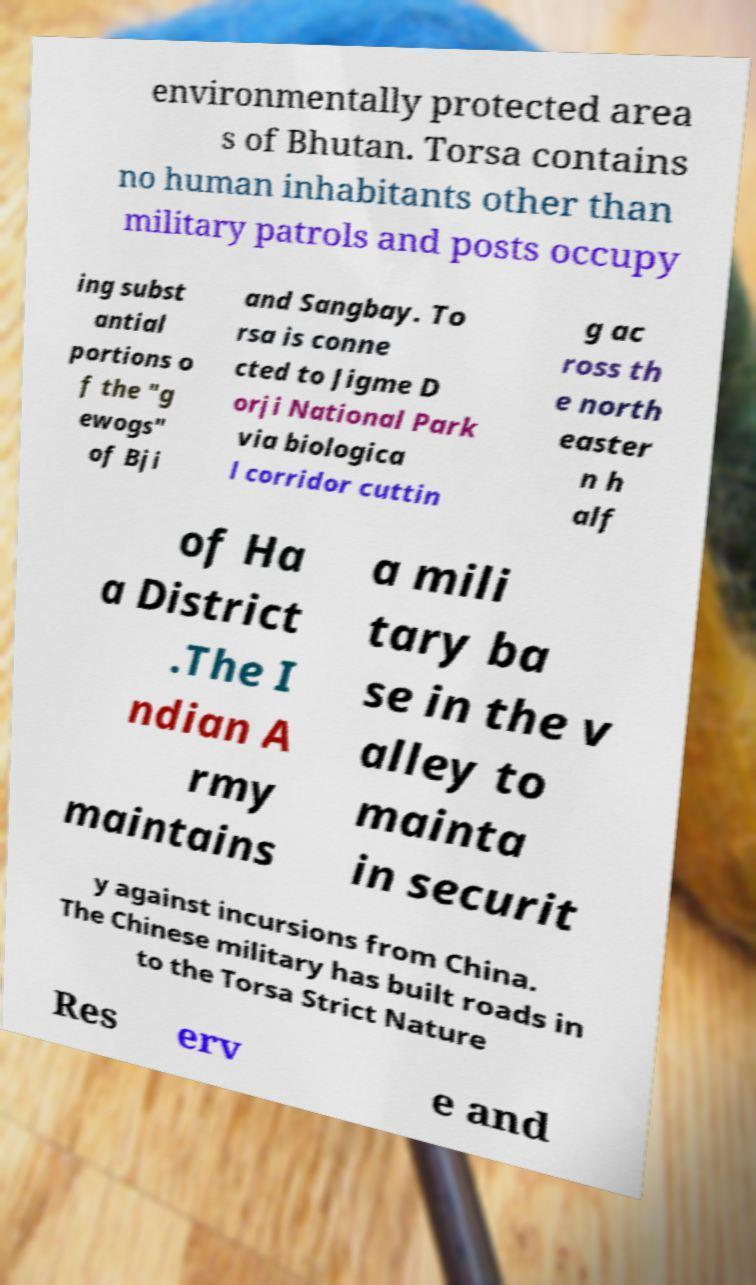I need the written content from this picture converted into text. Can you do that? environmentally protected area s of Bhutan. Torsa contains no human inhabitants other than military patrols and posts occupy ing subst antial portions o f the "g ewogs" of Bji and Sangbay. To rsa is conne cted to Jigme D orji National Park via biologica l corridor cuttin g ac ross th e north easter n h alf of Ha a District .The I ndian A rmy maintains a mili tary ba se in the v alley to mainta in securit y against incursions from China. The Chinese military has built roads in to the Torsa Strict Nature Res erv e and 